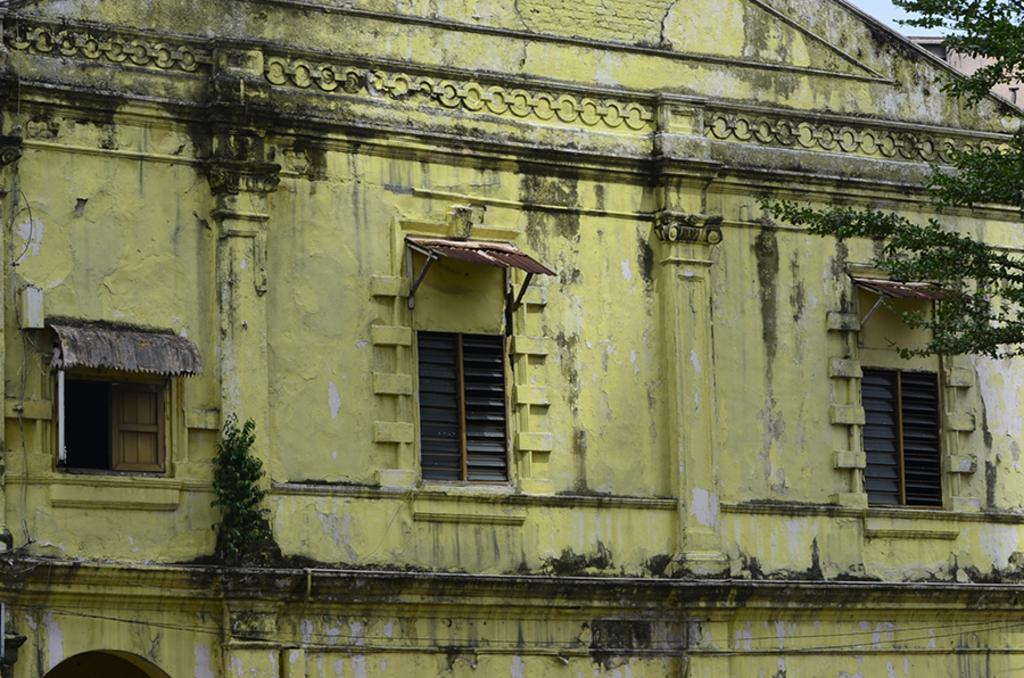What type of structure is visible in the image? There is a building with windows in the image. What natural elements can be seen in the image? There are branches of a tree and plants visible in the image. What is visible in the background of the image? The sky is visible in the image. How many jellyfish can be seen swimming in the sky in the image? There are no jellyfish visible in the image, as it features a building, tree branches, plants, and the sky. 